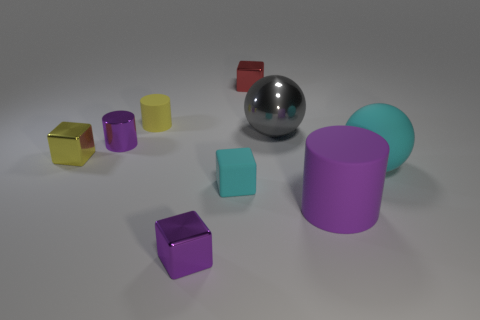Describe the lighting in this image. Where does it seem to be coming from? The lighting in the image appears soft and diffuse, suggesting an overhead source. This is indicated by the gentle shadows under the objects, which are cast slightly to the right, pointing to a light source from the upper left perspective. 